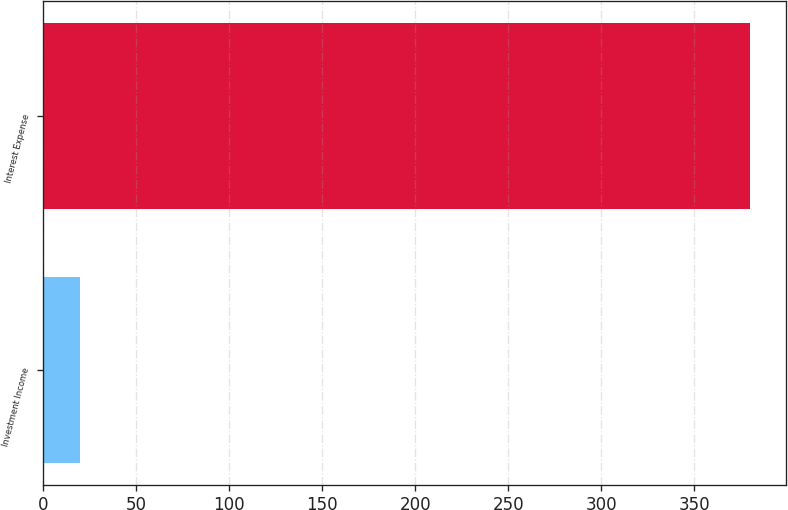Convert chart to OTSL. <chart><loc_0><loc_0><loc_500><loc_500><bar_chart><fcel>Investment Income<fcel>Interest Expense<nl><fcel>20<fcel>380<nl></chart> 